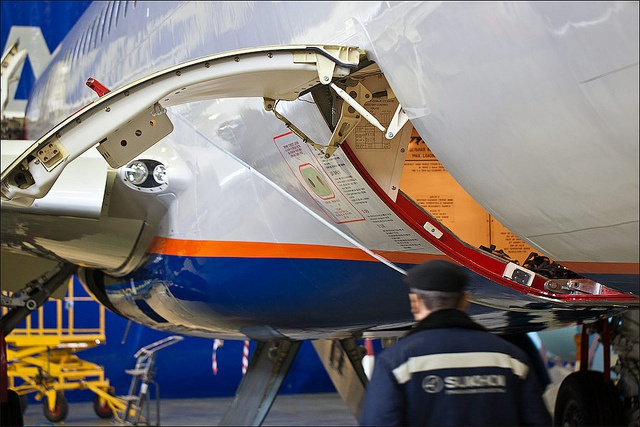Describe the objects in this image and their specific colors. I can see airplane in black, darkgray, lightgray, and gray tones and people in black, navy, gray, and darkgray tones in this image. 